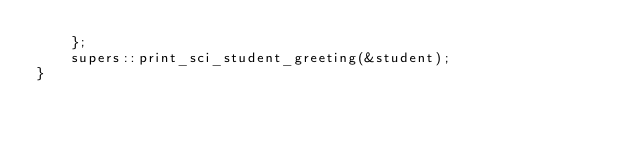Convert code to text. <code><loc_0><loc_0><loc_500><loc_500><_Rust_>    };
    supers::print_sci_student_greeting(&student);
}
</code> 